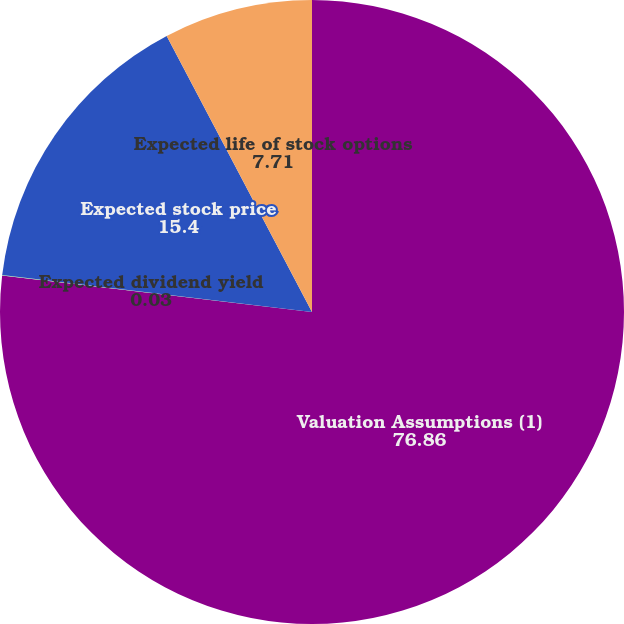<chart> <loc_0><loc_0><loc_500><loc_500><pie_chart><fcel>Valuation Assumptions (1)<fcel>Expected dividend yield<fcel>Expected stock price<fcel>Expected life of stock options<nl><fcel>76.86%<fcel>0.03%<fcel>15.4%<fcel>7.71%<nl></chart> 